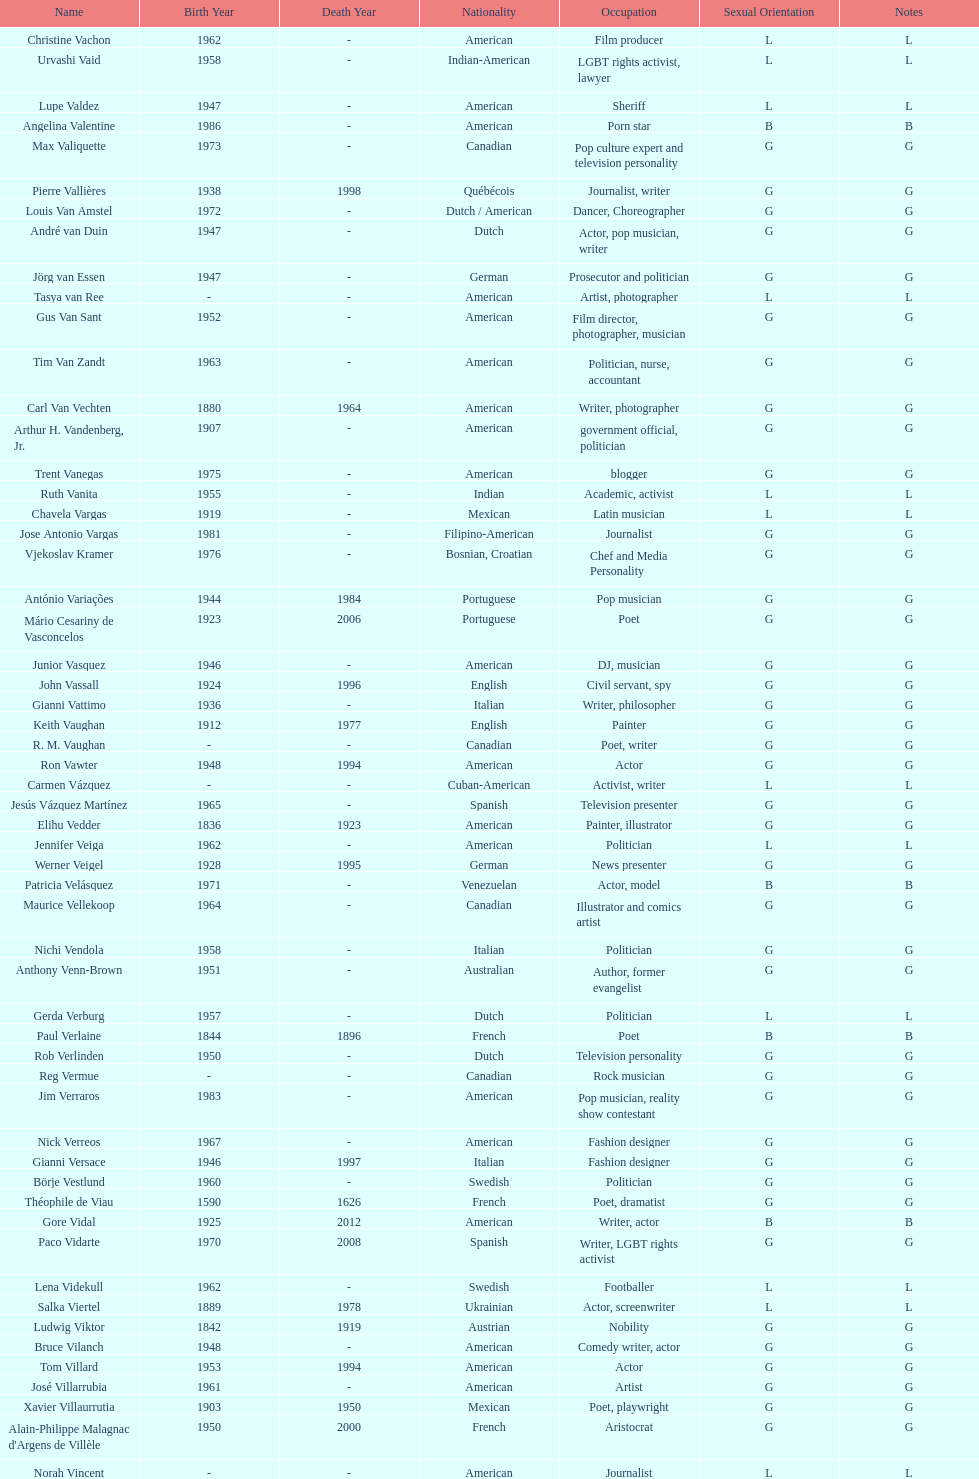Which nationality had the larger amount of names listed? American. 